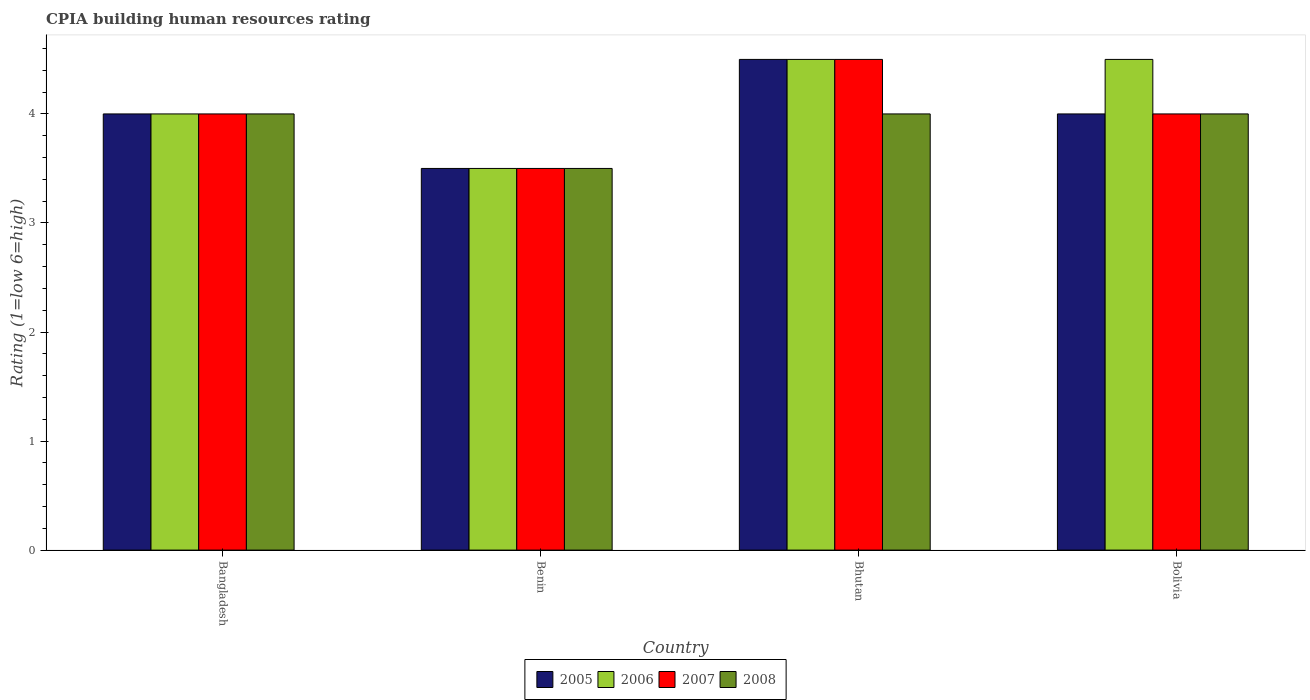How many bars are there on the 2nd tick from the left?
Give a very brief answer. 4. How many bars are there on the 4th tick from the right?
Give a very brief answer. 4. What is the label of the 3rd group of bars from the left?
Your answer should be compact. Bhutan. In how many cases, is the number of bars for a given country not equal to the number of legend labels?
Ensure brevity in your answer.  0. What is the CPIA rating in 2007 in Bangladesh?
Your answer should be very brief. 4. Across all countries, what is the maximum CPIA rating in 2005?
Your response must be concise. 4.5. In which country was the CPIA rating in 2006 maximum?
Your response must be concise. Bhutan. In which country was the CPIA rating in 2008 minimum?
Your answer should be very brief. Benin. What is the total CPIA rating in 2005 in the graph?
Your answer should be very brief. 16. What is the average CPIA rating in 2008 per country?
Your answer should be compact. 3.88. What is the difference between the CPIA rating of/in 2006 and CPIA rating of/in 2008 in Benin?
Your answer should be compact. 0. In how many countries, is the CPIA rating in 2007 greater than 2.6?
Your answer should be compact. 4. What is the ratio of the CPIA rating in 2005 in Bangladesh to that in Benin?
Provide a short and direct response. 1.14. Is the difference between the CPIA rating in 2006 in Bangladesh and Benin greater than the difference between the CPIA rating in 2008 in Bangladesh and Benin?
Your response must be concise. No. What is the difference between the highest and the second highest CPIA rating in 2006?
Your response must be concise. 0.5. Is it the case that in every country, the sum of the CPIA rating in 2007 and CPIA rating in 2006 is greater than the sum of CPIA rating in 2005 and CPIA rating in 2008?
Keep it short and to the point. No. What does the 2nd bar from the left in Bolivia represents?
Offer a very short reply. 2006. Is it the case that in every country, the sum of the CPIA rating in 2005 and CPIA rating in 2007 is greater than the CPIA rating in 2006?
Provide a short and direct response. Yes. Are all the bars in the graph horizontal?
Provide a short and direct response. No. How many countries are there in the graph?
Ensure brevity in your answer.  4. What is the difference between two consecutive major ticks on the Y-axis?
Provide a short and direct response. 1. Does the graph contain any zero values?
Make the answer very short. No. How are the legend labels stacked?
Provide a short and direct response. Horizontal. What is the title of the graph?
Make the answer very short. CPIA building human resources rating. Does "1969" appear as one of the legend labels in the graph?
Your response must be concise. No. What is the Rating (1=low 6=high) of 2005 in Benin?
Offer a very short reply. 3.5. What is the Rating (1=low 6=high) of 2008 in Benin?
Ensure brevity in your answer.  3.5. What is the Rating (1=low 6=high) of 2005 in Bhutan?
Offer a very short reply. 4.5. What is the Rating (1=low 6=high) in 2006 in Bhutan?
Ensure brevity in your answer.  4.5. What is the Rating (1=low 6=high) of 2008 in Bhutan?
Your answer should be very brief. 4. What is the Rating (1=low 6=high) in 2006 in Bolivia?
Ensure brevity in your answer.  4.5. Across all countries, what is the maximum Rating (1=low 6=high) of 2005?
Your answer should be very brief. 4.5. Across all countries, what is the maximum Rating (1=low 6=high) of 2007?
Ensure brevity in your answer.  4.5. Across all countries, what is the minimum Rating (1=low 6=high) of 2007?
Your response must be concise. 3.5. What is the total Rating (1=low 6=high) of 2006 in the graph?
Your response must be concise. 16.5. What is the total Rating (1=low 6=high) of 2008 in the graph?
Make the answer very short. 15.5. What is the difference between the Rating (1=low 6=high) in 2005 in Bangladesh and that in Benin?
Your answer should be very brief. 0.5. What is the difference between the Rating (1=low 6=high) of 2006 in Bangladesh and that in Benin?
Provide a short and direct response. 0.5. What is the difference between the Rating (1=low 6=high) of 2007 in Bangladesh and that in Benin?
Your answer should be very brief. 0.5. What is the difference between the Rating (1=low 6=high) in 2008 in Bangladesh and that in Benin?
Your response must be concise. 0.5. What is the difference between the Rating (1=low 6=high) of 2005 in Bangladesh and that in Bhutan?
Your answer should be compact. -0.5. What is the difference between the Rating (1=low 6=high) in 2006 in Bangladesh and that in Bhutan?
Give a very brief answer. -0.5. What is the difference between the Rating (1=low 6=high) of 2007 in Bangladesh and that in Bhutan?
Your response must be concise. -0.5. What is the difference between the Rating (1=low 6=high) in 2008 in Bangladesh and that in Bhutan?
Make the answer very short. 0. What is the difference between the Rating (1=low 6=high) of 2005 in Bangladesh and that in Bolivia?
Keep it short and to the point. 0. What is the difference between the Rating (1=low 6=high) of 2007 in Bangladesh and that in Bolivia?
Your answer should be compact. 0. What is the difference between the Rating (1=low 6=high) in 2006 in Benin and that in Bhutan?
Your answer should be very brief. -1. What is the difference between the Rating (1=low 6=high) of 2007 in Benin and that in Bhutan?
Offer a terse response. -1. What is the difference between the Rating (1=low 6=high) in 2005 in Benin and that in Bolivia?
Keep it short and to the point. -0.5. What is the difference between the Rating (1=low 6=high) of 2006 in Benin and that in Bolivia?
Provide a succinct answer. -1. What is the difference between the Rating (1=low 6=high) of 2007 in Benin and that in Bolivia?
Your answer should be very brief. -0.5. What is the difference between the Rating (1=low 6=high) in 2007 in Bhutan and that in Bolivia?
Provide a short and direct response. 0.5. What is the difference between the Rating (1=low 6=high) of 2005 in Bangladesh and the Rating (1=low 6=high) of 2006 in Benin?
Offer a very short reply. 0.5. What is the difference between the Rating (1=low 6=high) in 2005 in Bangladesh and the Rating (1=low 6=high) in 2007 in Benin?
Your response must be concise. 0.5. What is the difference between the Rating (1=low 6=high) in 2006 in Bangladesh and the Rating (1=low 6=high) in 2007 in Benin?
Ensure brevity in your answer.  0.5. What is the difference between the Rating (1=low 6=high) in 2006 in Bangladesh and the Rating (1=low 6=high) in 2008 in Benin?
Your answer should be very brief. 0.5. What is the difference between the Rating (1=low 6=high) in 2005 in Bangladesh and the Rating (1=low 6=high) in 2006 in Bhutan?
Keep it short and to the point. -0.5. What is the difference between the Rating (1=low 6=high) of 2005 in Bangladesh and the Rating (1=low 6=high) of 2007 in Bhutan?
Keep it short and to the point. -0.5. What is the difference between the Rating (1=low 6=high) in 2005 in Bangladesh and the Rating (1=low 6=high) in 2008 in Bhutan?
Provide a succinct answer. 0. What is the difference between the Rating (1=low 6=high) of 2006 in Bangladesh and the Rating (1=low 6=high) of 2008 in Bhutan?
Provide a short and direct response. 0. What is the difference between the Rating (1=low 6=high) in 2007 in Bangladesh and the Rating (1=low 6=high) in 2008 in Bhutan?
Make the answer very short. 0. What is the difference between the Rating (1=low 6=high) in 2005 in Bangladesh and the Rating (1=low 6=high) in 2008 in Bolivia?
Offer a terse response. 0. What is the difference between the Rating (1=low 6=high) of 2006 in Bangladesh and the Rating (1=low 6=high) of 2008 in Bolivia?
Offer a terse response. 0. What is the difference between the Rating (1=low 6=high) in 2005 in Benin and the Rating (1=low 6=high) in 2006 in Bhutan?
Provide a short and direct response. -1. What is the difference between the Rating (1=low 6=high) in 2005 in Benin and the Rating (1=low 6=high) in 2007 in Bhutan?
Offer a terse response. -1. What is the difference between the Rating (1=low 6=high) of 2006 in Benin and the Rating (1=low 6=high) of 2008 in Bhutan?
Your answer should be compact. -0.5. What is the difference between the Rating (1=low 6=high) of 2005 in Benin and the Rating (1=low 6=high) of 2006 in Bolivia?
Offer a terse response. -1. What is the difference between the Rating (1=low 6=high) of 2005 in Benin and the Rating (1=low 6=high) of 2007 in Bolivia?
Make the answer very short. -0.5. What is the difference between the Rating (1=low 6=high) of 2005 in Benin and the Rating (1=low 6=high) of 2008 in Bolivia?
Your answer should be very brief. -0.5. What is the difference between the Rating (1=low 6=high) of 2006 in Benin and the Rating (1=low 6=high) of 2007 in Bolivia?
Your answer should be compact. -0.5. What is the difference between the Rating (1=low 6=high) of 2005 in Bhutan and the Rating (1=low 6=high) of 2006 in Bolivia?
Your answer should be very brief. 0. What is the difference between the Rating (1=low 6=high) of 2005 in Bhutan and the Rating (1=low 6=high) of 2007 in Bolivia?
Ensure brevity in your answer.  0.5. What is the difference between the Rating (1=low 6=high) in 2005 in Bhutan and the Rating (1=low 6=high) in 2008 in Bolivia?
Keep it short and to the point. 0.5. What is the difference between the Rating (1=low 6=high) in 2006 in Bhutan and the Rating (1=low 6=high) in 2007 in Bolivia?
Offer a terse response. 0.5. What is the difference between the Rating (1=low 6=high) in 2007 in Bhutan and the Rating (1=low 6=high) in 2008 in Bolivia?
Your answer should be compact. 0.5. What is the average Rating (1=low 6=high) of 2006 per country?
Provide a succinct answer. 4.12. What is the average Rating (1=low 6=high) in 2007 per country?
Provide a short and direct response. 4. What is the average Rating (1=low 6=high) of 2008 per country?
Your answer should be very brief. 3.88. What is the difference between the Rating (1=low 6=high) in 2005 and Rating (1=low 6=high) in 2007 in Bangladesh?
Give a very brief answer. 0. What is the difference between the Rating (1=low 6=high) in 2005 and Rating (1=low 6=high) in 2008 in Bangladesh?
Provide a succinct answer. 0. What is the difference between the Rating (1=low 6=high) of 2006 and Rating (1=low 6=high) of 2008 in Bangladesh?
Your answer should be compact. 0. What is the difference between the Rating (1=low 6=high) in 2005 and Rating (1=low 6=high) in 2006 in Benin?
Offer a terse response. 0. What is the difference between the Rating (1=low 6=high) in 2005 and Rating (1=low 6=high) in 2008 in Benin?
Ensure brevity in your answer.  0. What is the difference between the Rating (1=low 6=high) of 2007 and Rating (1=low 6=high) of 2008 in Benin?
Give a very brief answer. 0. What is the difference between the Rating (1=low 6=high) in 2005 and Rating (1=low 6=high) in 2006 in Bhutan?
Give a very brief answer. 0. What is the difference between the Rating (1=low 6=high) of 2005 and Rating (1=low 6=high) of 2008 in Bhutan?
Your response must be concise. 0.5. What is the difference between the Rating (1=low 6=high) in 2005 and Rating (1=low 6=high) in 2006 in Bolivia?
Provide a short and direct response. -0.5. What is the difference between the Rating (1=low 6=high) in 2006 and Rating (1=low 6=high) in 2007 in Bolivia?
Make the answer very short. 0.5. What is the difference between the Rating (1=low 6=high) in 2006 and Rating (1=low 6=high) in 2008 in Bolivia?
Offer a terse response. 0.5. What is the difference between the Rating (1=low 6=high) of 2007 and Rating (1=low 6=high) of 2008 in Bolivia?
Keep it short and to the point. 0. What is the ratio of the Rating (1=low 6=high) in 2005 in Bangladesh to that in Bhutan?
Give a very brief answer. 0.89. What is the ratio of the Rating (1=low 6=high) in 2006 in Bangladesh to that in Bhutan?
Provide a short and direct response. 0.89. What is the ratio of the Rating (1=low 6=high) in 2007 in Bangladesh to that in Bhutan?
Offer a very short reply. 0.89. What is the ratio of the Rating (1=low 6=high) of 2008 in Bangladesh to that in Bhutan?
Provide a succinct answer. 1. What is the ratio of the Rating (1=low 6=high) of 2006 in Bangladesh to that in Bolivia?
Your answer should be compact. 0.89. What is the ratio of the Rating (1=low 6=high) of 2006 in Benin to that in Bhutan?
Give a very brief answer. 0.78. What is the ratio of the Rating (1=low 6=high) of 2005 in Benin to that in Bolivia?
Give a very brief answer. 0.88. What is the ratio of the Rating (1=low 6=high) of 2005 in Bhutan to that in Bolivia?
Provide a short and direct response. 1.12. What is the ratio of the Rating (1=low 6=high) in 2006 in Bhutan to that in Bolivia?
Give a very brief answer. 1. What is the difference between the highest and the second highest Rating (1=low 6=high) of 2005?
Ensure brevity in your answer.  0.5. What is the difference between the highest and the lowest Rating (1=low 6=high) in 2006?
Ensure brevity in your answer.  1. What is the difference between the highest and the lowest Rating (1=low 6=high) in 2008?
Your answer should be very brief. 0.5. 